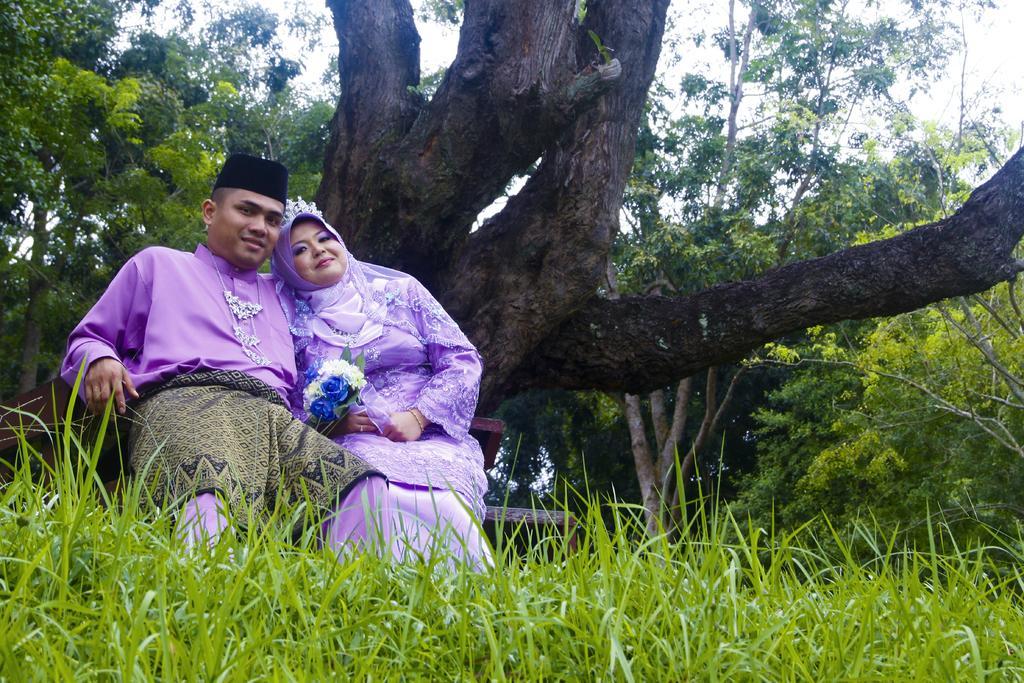Please provide a concise description of this image. In this image there is a man and a woman sitting on a bench, in front of them there is grass, in the background there are trees. 